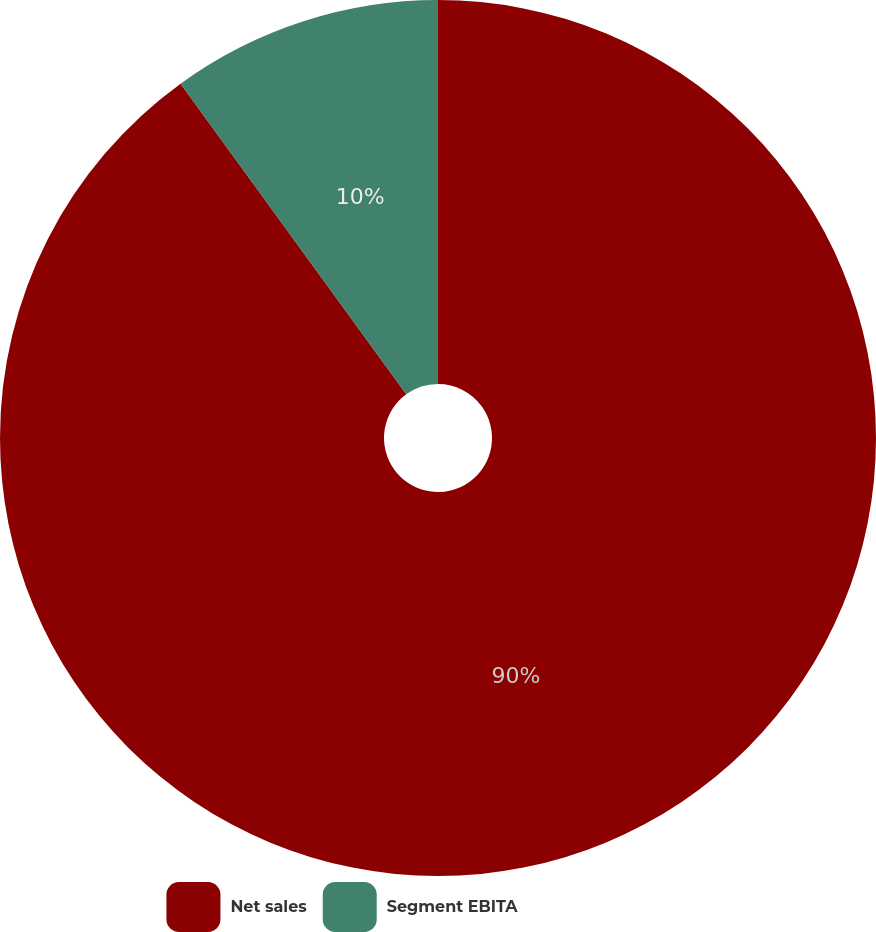Convert chart. <chart><loc_0><loc_0><loc_500><loc_500><pie_chart><fcel>Net sales<fcel>Segment EBITA<nl><fcel>90.0%<fcel>10.0%<nl></chart> 